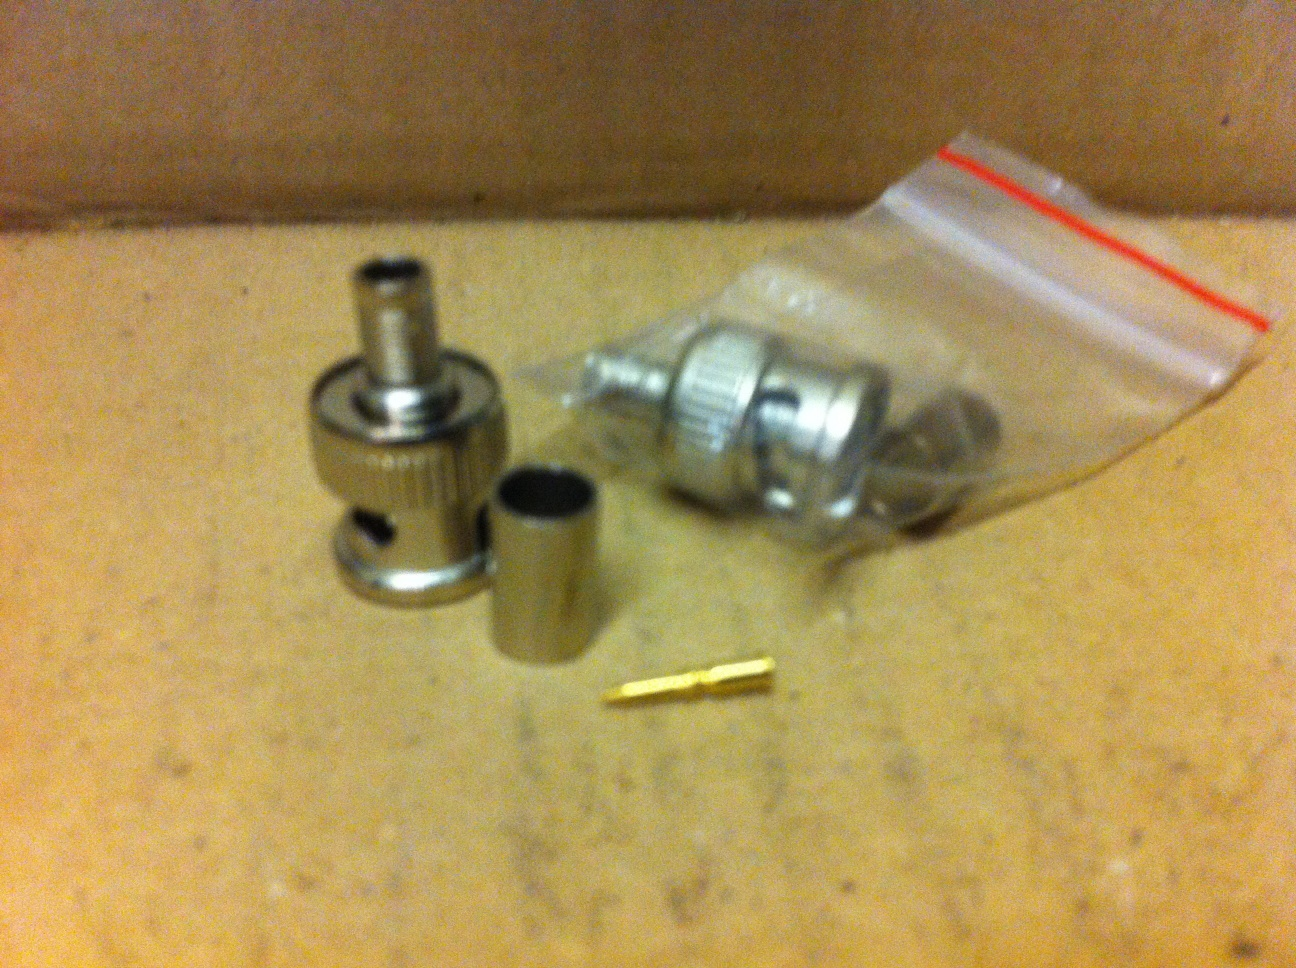Imagine if these parts had a unique function beyond their usual purpose. Can you come up with a creative use for them? Absolutely! Let's imagine these parts were repurposed into a tiny mechanical puzzle. Each piece would function as a part of a miniature locking mechanism. The brass pin could serve as a key that needs to be aligned precisely to unlock the housing. The barrel sleeve would then slide open to reveal a hidden compartment for storing small valuable items or micro messages. It could be an intriguing gadget for puzzle enthusiasts! 